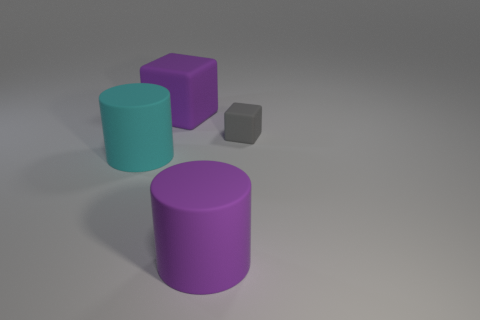What is the shape of the large thing that is the same color as the big matte block?
Provide a short and direct response. Cylinder. What is the size of the cylinder that is on the left side of the large purple rubber object behind the large rubber cylinder that is in front of the cyan cylinder?
Your response must be concise. Large. What number of other objects are there of the same material as the purple cylinder?
Keep it short and to the point. 3. There is a matte cylinder left of the purple cylinder; what size is it?
Provide a succinct answer. Large. What number of objects are in front of the big cube and on the right side of the large cyan thing?
Offer a terse response. 2. What material is the big object that is left of the large matte thing that is behind the gray thing made of?
Ensure brevity in your answer.  Rubber. What is the material of the other object that is the same shape as the tiny gray object?
Provide a short and direct response. Rubber. Are any brown matte things visible?
Your response must be concise. No. What shape is the gray object that is made of the same material as the large cyan thing?
Your answer should be compact. Cube. There is a cube that is right of the large cube; what material is it?
Offer a very short reply. Rubber. 